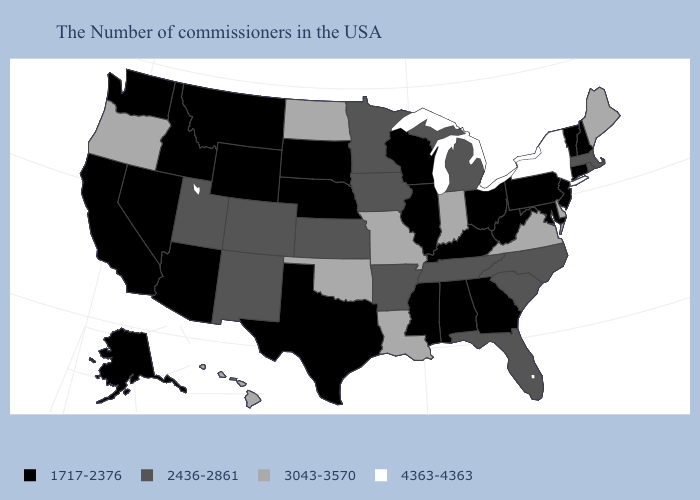What is the value of Massachusetts?
Be succinct. 2436-2861. Does Rhode Island have the lowest value in the USA?
Give a very brief answer. No. Among the states that border Oregon , which have the lowest value?
Keep it brief. Idaho, Nevada, California, Washington. What is the value of New Hampshire?
Write a very short answer. 1717-2376. Does Illinois have the same value as Pennsylvania?
Short answer required. Yes. Among the states that border Oklahoma , does Missouri have the highest value?
Give a very brief answer. Yes. What is the highest value in the USA?
Answer briefly. 4363-4363. What is the highest value in the South ?
Write a very short answer. 3043-3570. What is the value of Oregon?
Answer briefly. 3043-3570. What is the highest value in the USA?
Write a very short answer. 4363-4363. Which states have the lowest value in the USA?
Concise answer only. New Hampshire, Vermont, Connecticut, New Jersey, Maryland, Pennsylvania, West Virginia, Ohio, Georgia, Kentucky, Alabama, Wisconsin, Illinois, Mississippi, Nebraska, Texas, South Dakota, Wyoming, Montana, Arizona, Idaho, Nevada, California, Washington, Alaska. What is the highest value in the USA?
Quick response, please. 4363-4363. Does New York have the highest value in the USA?
Short answer required. Yes. Among the states that border Arizona , does Utah have the lowest value?
Quick response, please. No. Name the states that have a value in the range 4363-4363?
Concise answer only. New York. 